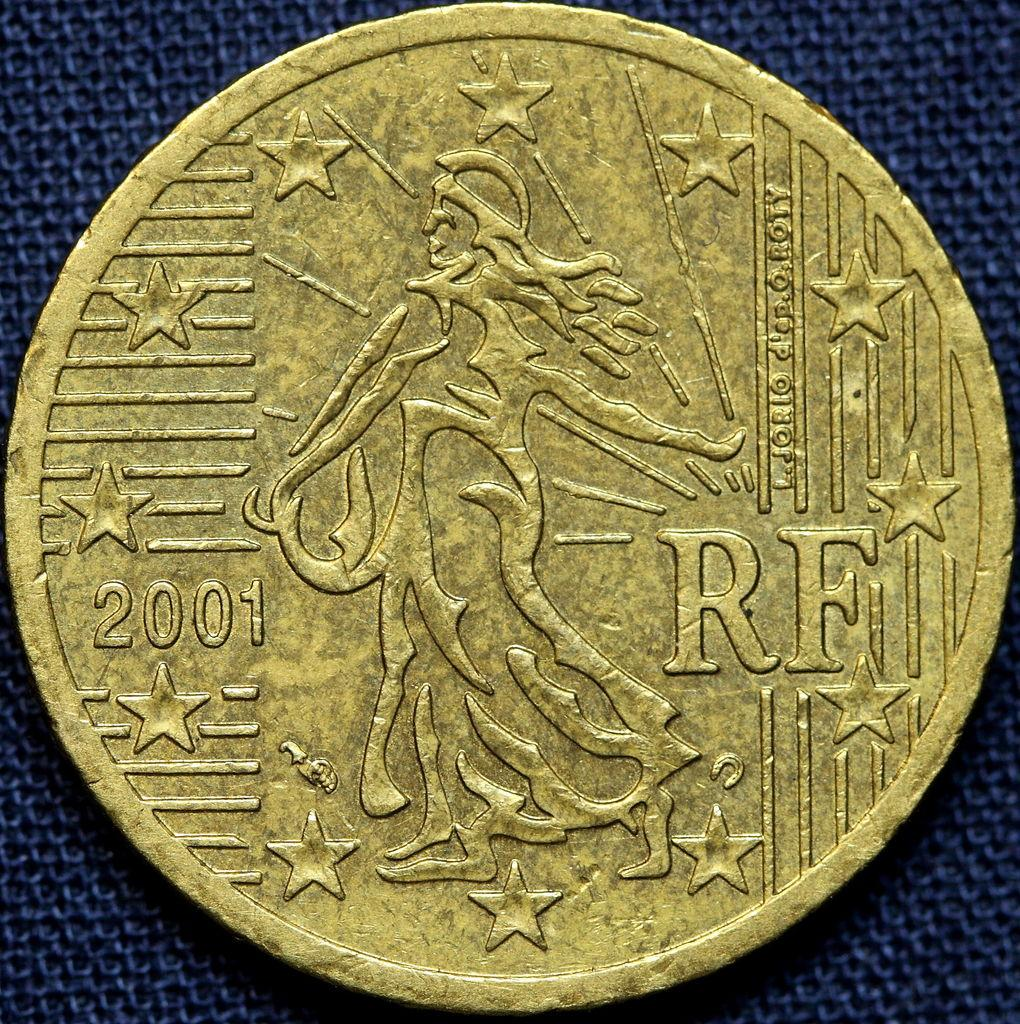<image>
Create a compact narrative representing the image presented. A coin has a section missing and is dated 2001. 